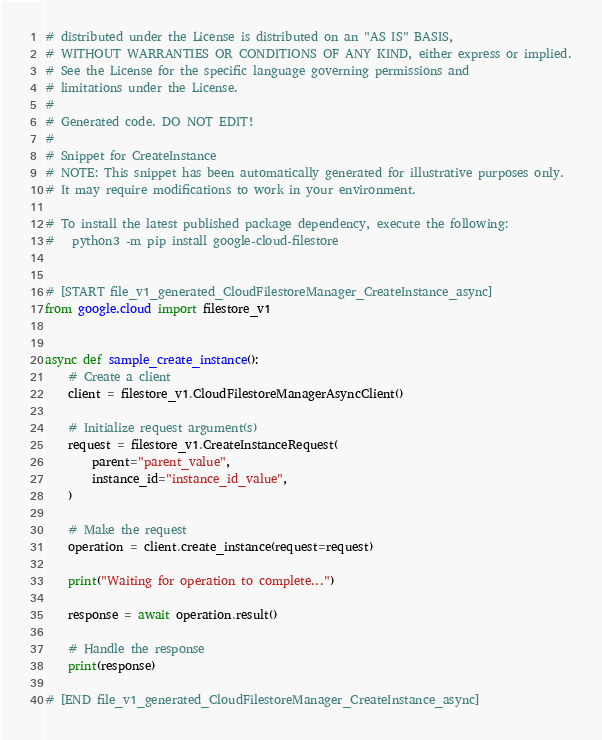<code> <loc_0><loc_0><loc_500><loc_500><_Python_># distributed under the License is distributed on an "AS IS" BASIS,
# WITHOUT WARRANTIES OR CONDITIONS OF ANY KIND, either express or implied.
# See the License for the specific language governing permissions and
# limitations under the License.
#
# Generated code. DO NOT EDIT!
#
# Snippet for CreateInstance
# NOTE: This snippet has been automatically generated for illustrative purposes only.
# It may require modifications to work in your environment.

# To install the latest published package dependency, execute the following:
#   python3 -m pip install google-cloud-filestore


# [START file_v1_generated_CloudFilestoreManager_CreateInstance_async]
from google.cloud import filestore_v1


async def sample_create_instance():
    # Create a client
    client = filestore_v1.CloudFilestoreManagerAsyncClient()

    # Initialize request argument(s)
    request = filestore_v1.CreateInstanceRequest(
        parent="parent_value",
        instance_id="instance_id_value",
    )

    # Make the request
    operation = client.create_instance(request=request)

    print("Waiting for operation to complete...")

    response = await operation.result()

    # Handle the response
    print(response)

# [END file_v1_generated_CloudFilestoreManager_CreateInstance_async]
</code> 